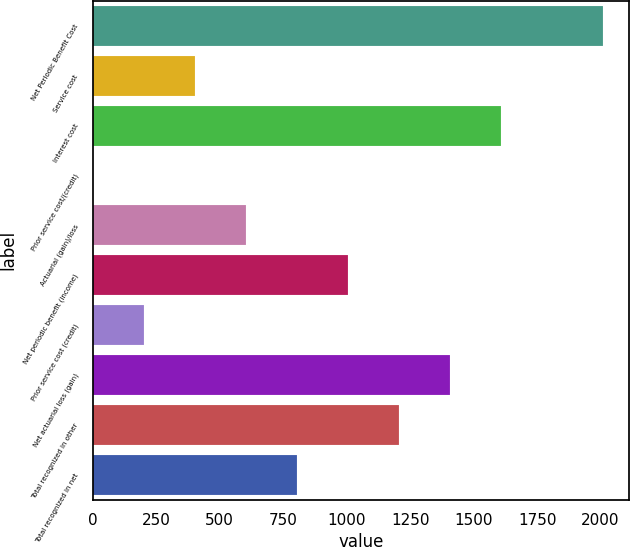<chart> <loc_0><loc_0><loc_500><loc_500><bar_chart><fcel>Net Periodic Benefit Cost<fcel>Service cost<fcel>Interest cost<fcel>Prior service cost/(credit)<fcel>Actuarial (gain)/loss<fcel>Net periodic benefit (income)<fcel>Prior service cost (credit)<fcel>Net actuarial loss (gain)<fcel>Total recognized in other<fcel>Total recognized in net<nl><fcel>2011<fcel>402.92<fcel>1608.98<fcel>0.9<fcel>603.93<fcel>1005.95<fcel>201.91<fcel>1407.97<fcel>1206.96<fcel>804.94<nl></chart> 